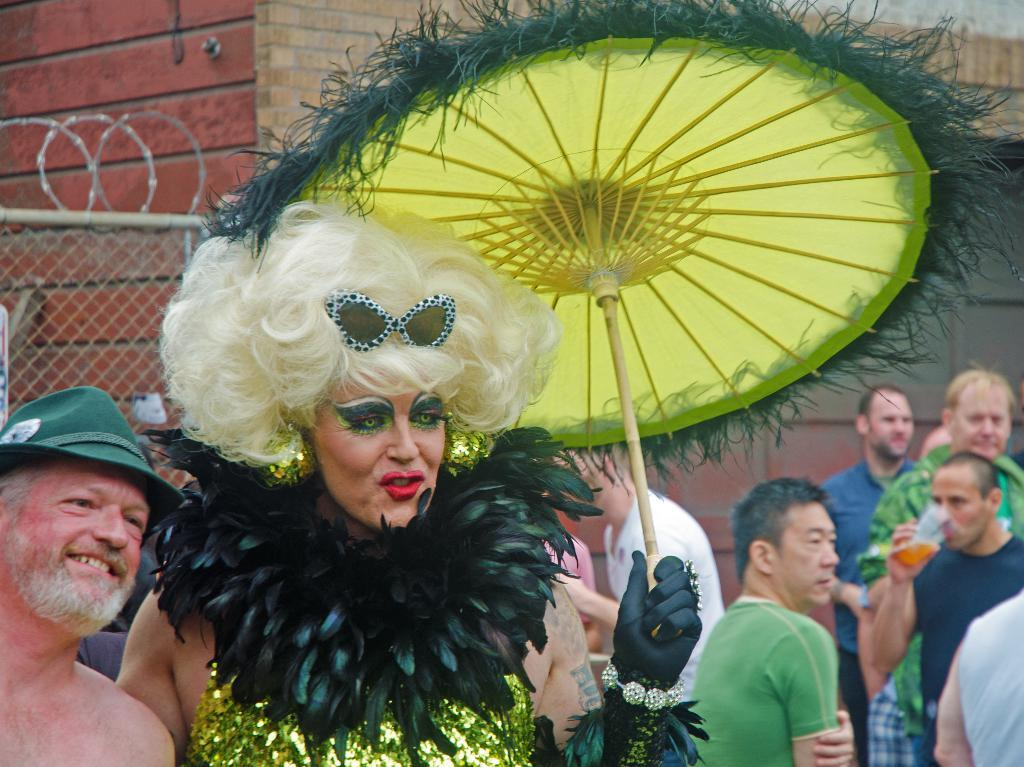What can be seen at the bottom of the image? There are people standing at the bottom of the image. What are the people holding in their hands? The people are holding something. What is located behind the people in the image? There is a wall behind the people. Can you see a river flowing behind the people in the image? There is no river visible in the image; it only shows a wall behind the people. 